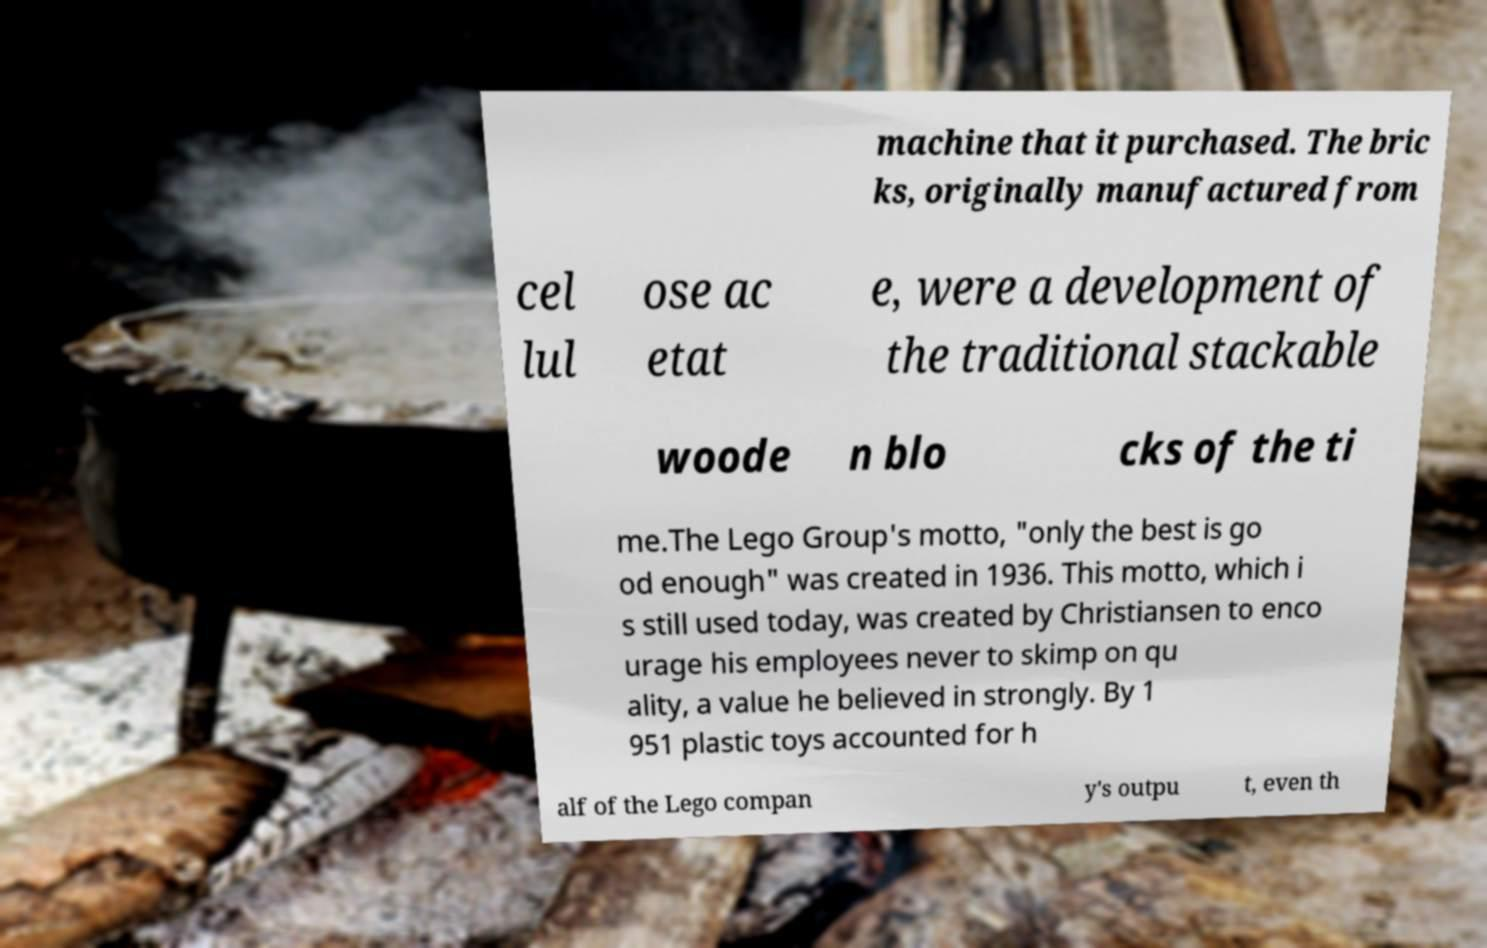Please identify and transcribe the text found in this image. machine that it purchased. The bric ks, originally manufactured from cel lul ose ac etat e, were a development of the traditional stackable woode n blo cks of the ti me.The Lego Group's motto, "only the best is go od enough" was created in 1936. This motto, which i s still used today, was created by Christiansen to enco urage his employees never to skimp on qu ality, a value he believed in strongly. By 1 951 plastic toys accounted for h alf of the Lego compan y's outpu t, even th 